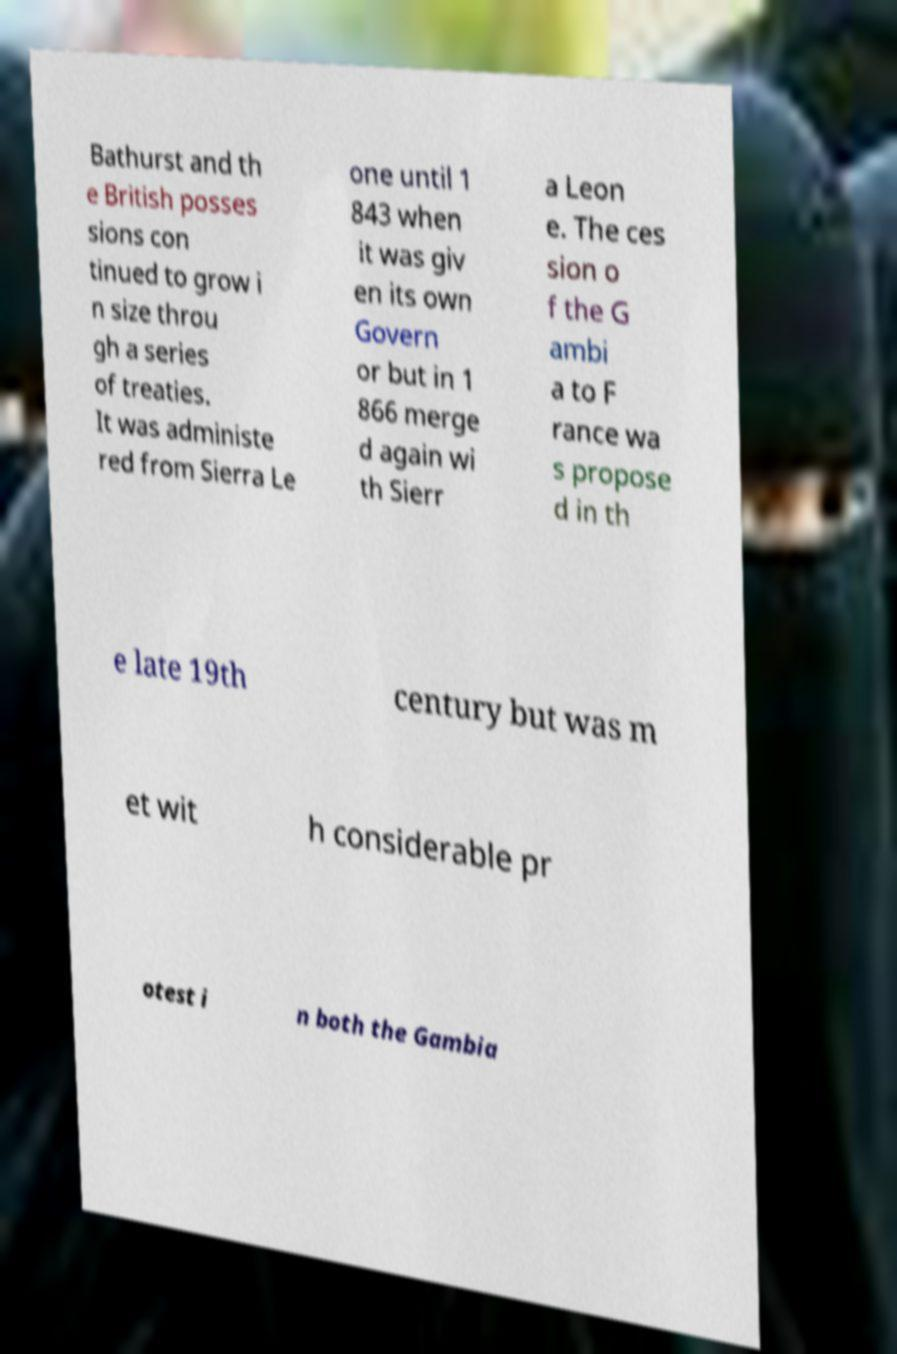There's text embedded in this image that I need extracted. Can you transcribe it verbatim? Bathurst and th e British posses sions con tinued to grow i n size throu gh a series of treaties. It was administe red from Sierra Le one until 1 843 when it was giv en its own Govern or but in 1 866 merge d again wi th Sierr a Leon e. The ces sion o f the G ambi a to F rance wa s propose d in th e late 19th century but was m et wit h considerable pr otest i n both the Gambia 